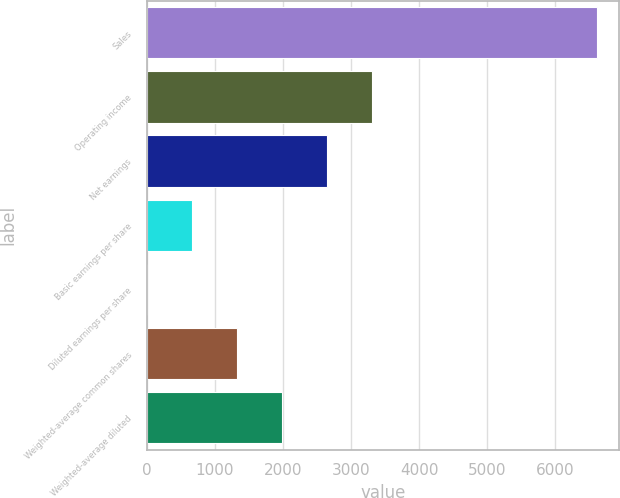Convert chart. <chart><loc_0><loc_0><loc_500><loc_500><bar_chart><fcel>Sales<fcel>Operating income<fcel>Net earnings<fcel>Basic earnings per share<fcel>Diluted earnings per share<fcel>Weighted-average common shares<fcel>Weighted-average diluted<nl><fcel>6612<fcel>3306.91<fcel>2645.9<fcel>662.87<fcel>1.86<fcel>1323.88<fcel>1984.89<nl></chart> 